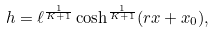Convert formula to latex. <formula><loc_0><loc_0><loc_500><loc_500>h = \ell ^ { \frac { 1 } { K + 1 } } \cosh ^ { \frac { 1 } { K + 1 } } ( r x + x _ { 0 } ) ,</formula> 